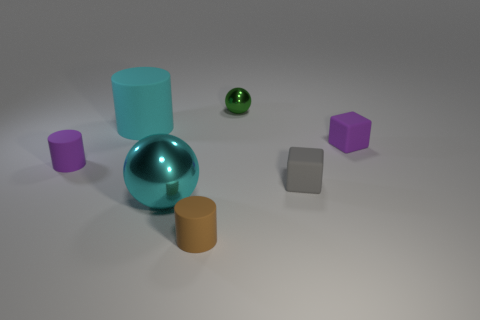Subtract all tiny matte cylinders. How many cylinders are left? 1 Add 2 cubes. How many objects exist? 9 Subtract all yellow cylinders. Subtract all brown spheres. How many cylinders are left? 3 Subtract all spheres. How many objects are left? 5 Add 2 large cyan metallic things. How many large cyan metallic things are left? 3 Add 4 tiny gray things. How many tiny gray things exist? 5 Subtract 1 purple cylinders. How many objects are left? 6 Subtract all gray rubber cubes. Subtract all gray matte cubes. How many objects are left? 5 